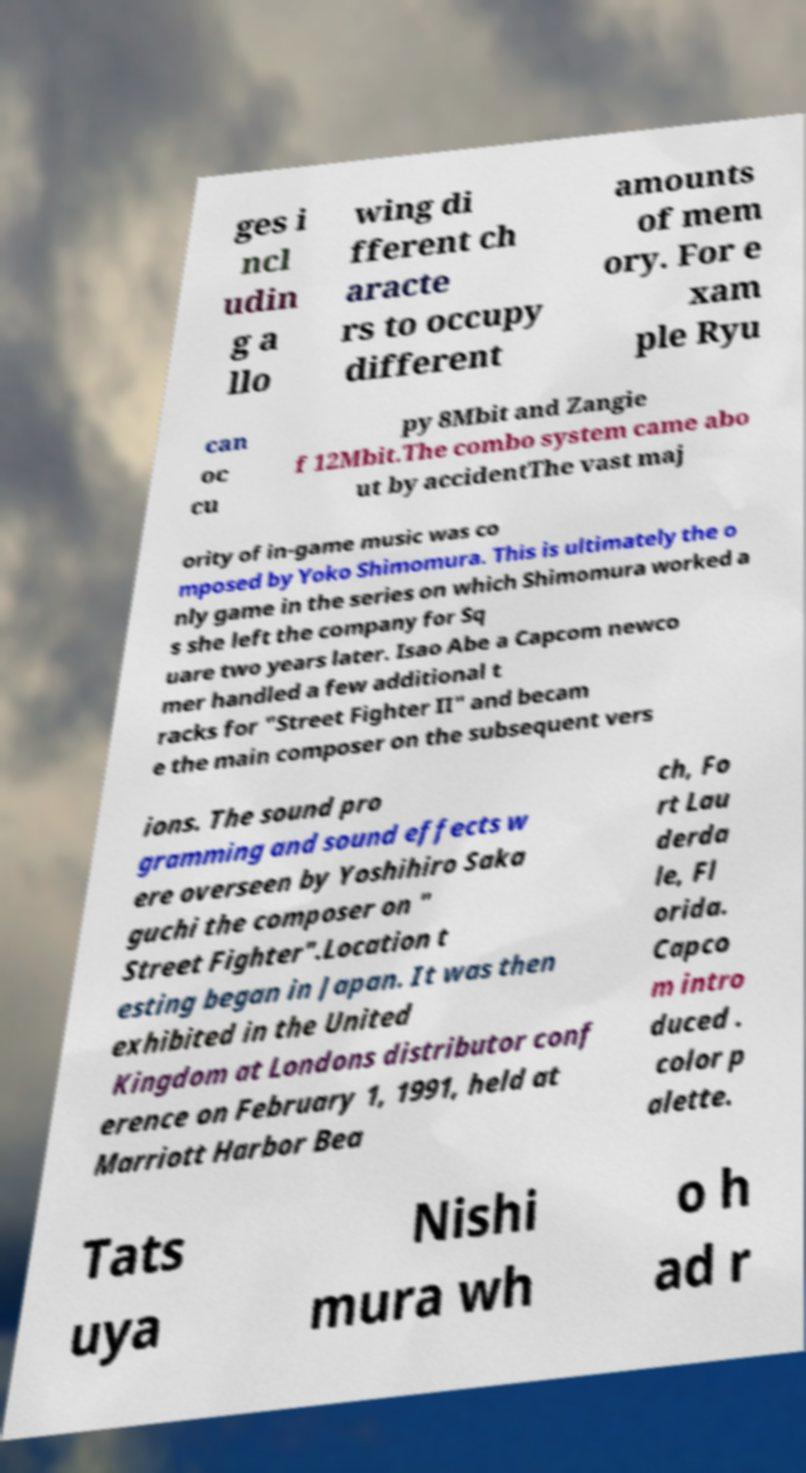I need the written content from this picture converted into text. Can you do that? ges i ncl udin g a llo wing di fferent ch aracte rs to occupy different amounts of mem ory. For e xam ple Ryu can oc cu py 8Mbit and Zangie f 12Mbit.The combo system came abo ut by accidentThe vast maj ority of in-game music was co mposed by Yoko Shimomura. This is ultimately the o nly game in the series on which Shimomura worked a s she left the company for Sq uare two years later. Isao Abe a Capcom newco mer handled a few additional t racks for "Street Fighter II" and becam e the main composer on the subsequent vers ions. The sound pro gramming and sound effects w ere overseen by Yoshihiro Saka guchi the composer on " Street Fighter".Location t esting began in Japan. It was then exhibited in the United Kingdom at Londons distributor conf erence on February 1, 1991, held at Marriott Harbor Bea ch, Fo rt Lau derda le, Fl orida. Capco m intro duced . color p alette. Tats uya Nishi mura wh o h ad r 